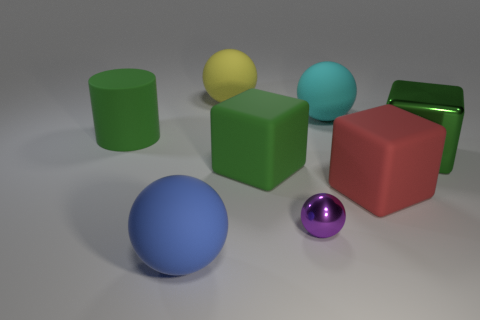Is there anything else that has the same size as the purple object?
Your answer should be very brief. No. There is a matte object that is the same color as the big cylinder; what size is it?
Your answer should be compact. Large. What number of objects are either tiny purple shiny blocks or matte blocks?
Keep it short and to the point. 2. What shape is the rubber object that is both in front of the big green matte block and on the right side of the purple metallic ball?
Provide a succinct answer. Cube. There is a yellow object; is its shape the same as the green thing that is to the left of the big blue thing?
Provide a succinct answer. No. There is a purple metallic thing; are there any big red things behind it?
Give a very brief answer. Yes. There is another large cube that is the same color as the metallic block; what is it made of?
Make the answer very short. Rubber. What number of balls are either tiny metallic objects or large blue rubber objects?
Keep it short and to the point. 2. Is the large red rubber thing the same shape as the green metal thing?
Ensure brevity in your answer.  Yes. There is a green block that is right of the purple shiny object; what size is it?
Provide a short and direct response. Large. 